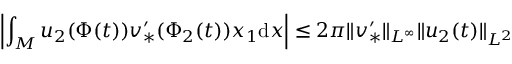Convert formula to latex. <formula><loc_0><loc_0><loc_500><loc_500>\left | \int _ { M } u _ { 2 } ( \Phi ( t ) ) v _ { * } ^ { \prime } ( \Phi _ { 2 } ( t ) ) x _ { 1 } d x \right | \leq 2 \pi \| v _ { * } ^ { \prime } \| _ { L ^ { \infty } } \| u _ { 2 } ( t ) \| _ { L ^ { 2 } }</formula> 